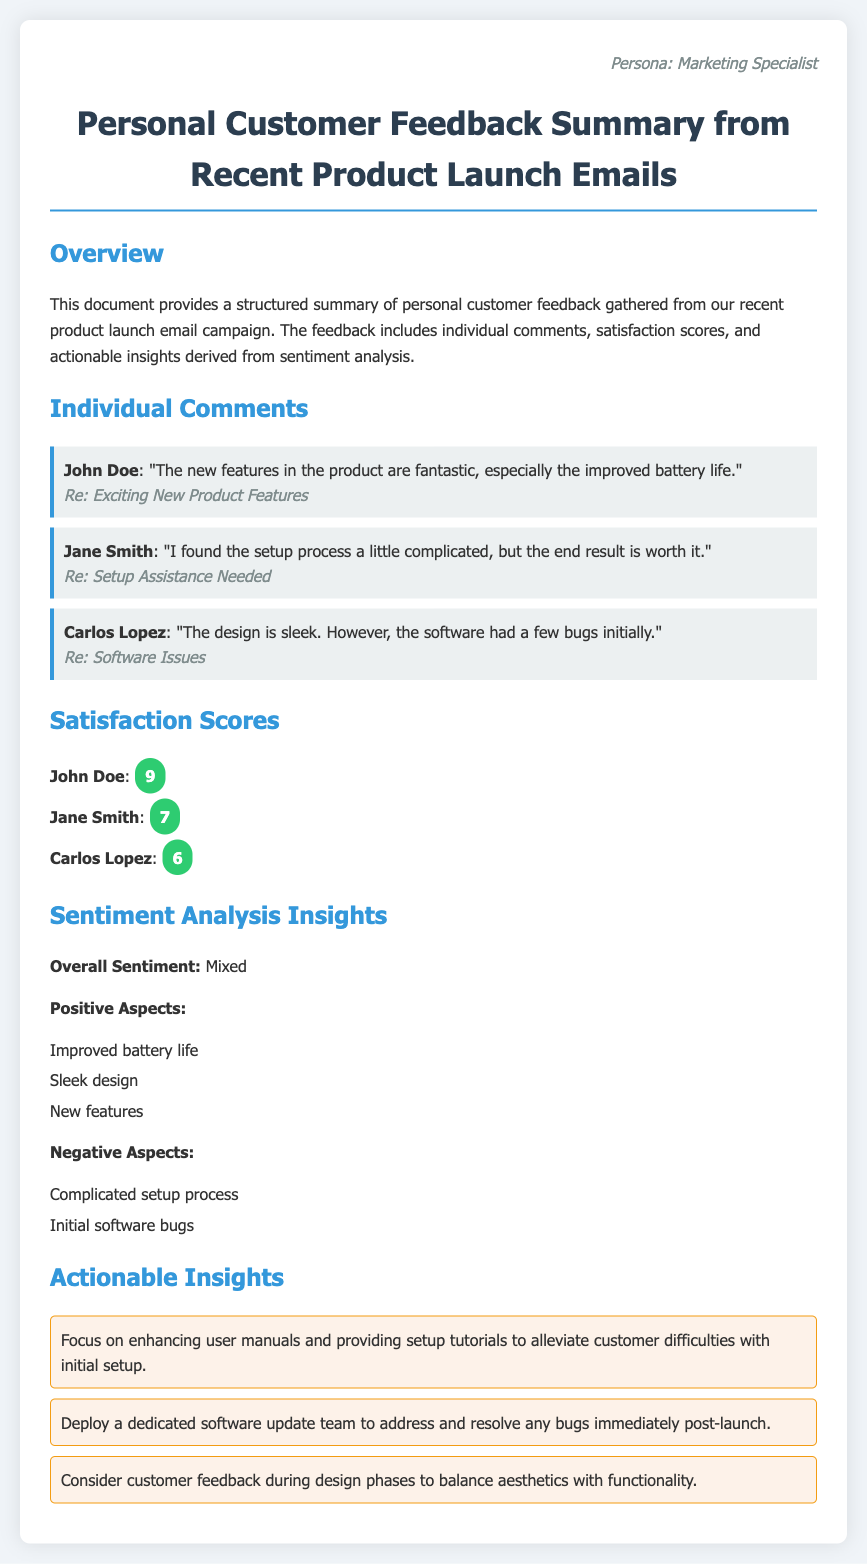What is the name of the first commenter? The first comment in the document is from John Doe.
Answer: John Doe What satisfaction score did Jane Smith give? The satisfaction score for Jane Smith listed in the document is 7.
Answer: 7 What positive aspect is mentioned regarding the product? Among the positive aspects listed, "Improved battery life" is highlighted.
Answer: Improved battery life What is a negative aspect noted in the feedback? The document states that "Initial software bugs" is one of the negative aspects.
Answer: Initial software bugs How many actionable insights are provided in the document? There are three actionable insights mentioned in the summary.
Answer: 3 What was Carlos Lopez's satisfaction score? The satisfaction score for Carlos Lopez indicated in the document is 6.
Answer: 6 What was the overall sentiment captured from the feedback? The overall sentiment derived from the feedback is described as "Mixed."
Answer: Mixed Which feature did John Doe particularly appreciate? John Doe mentioned that "the improved battery life" is fantastic.
Answer: improved battery life What is suggested to alleviate difficulties with initial setup? The document suggests enhancing user manuals and providing setup tutorials.
Answer: Enhance user manuals and provide setup tutorials 